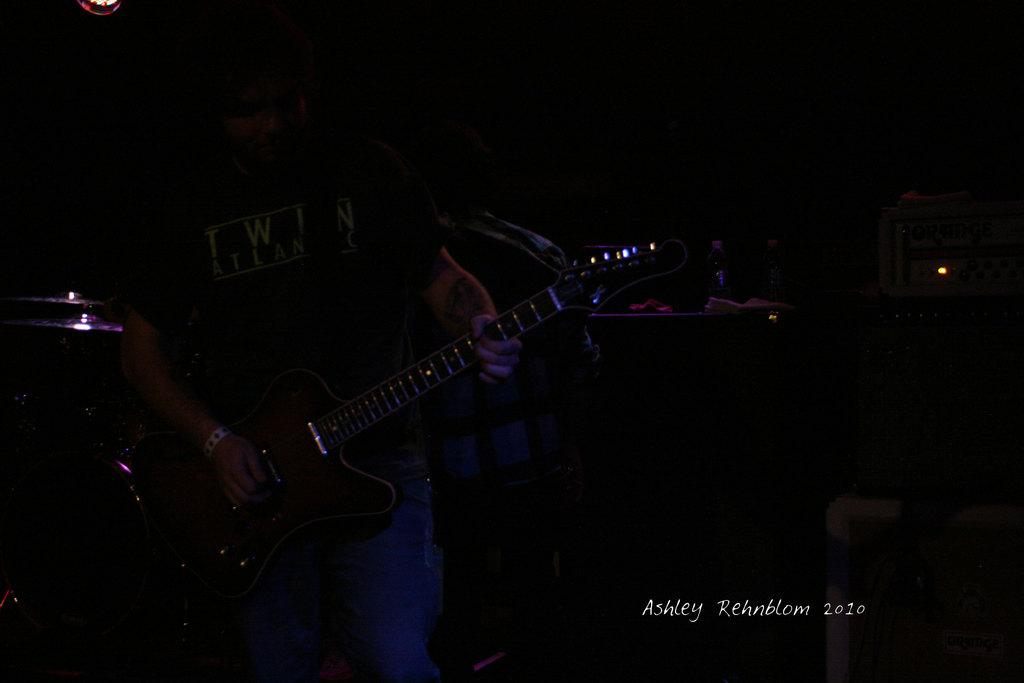What is the overall lighting condition in the image? The image is dark. Can you describe the person in the image? There is a person in the image, and they are standing. What is the person holding in the image? The person is holding a guitar. What type of stocking is the person wearing in the image? There is no mention of stockings or any clothing details in the image, so it cannot be determined what type of stocking the person might be wearing. 